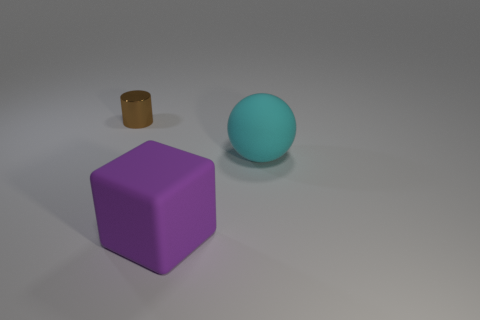Add 2 big blue shiny things. How many objects exist? 5 Subtract 1 cylinders. How many cylinders are left? 0 Subtract all cylinders. How many objects are left? 2 Subtract all purple spheres. Subtract all green cylinders. How many spheres are left? 1 Subtract all purple cubes. Subtract all cylinders. How many objects are left? 1 Add 1 large rubber objects. How many large rubber objects are left? 3 Add 1 large blue matte objects. How many large blue matte objects exist? 1 Subtract 1 purple cubes. How many objects are left? 2 